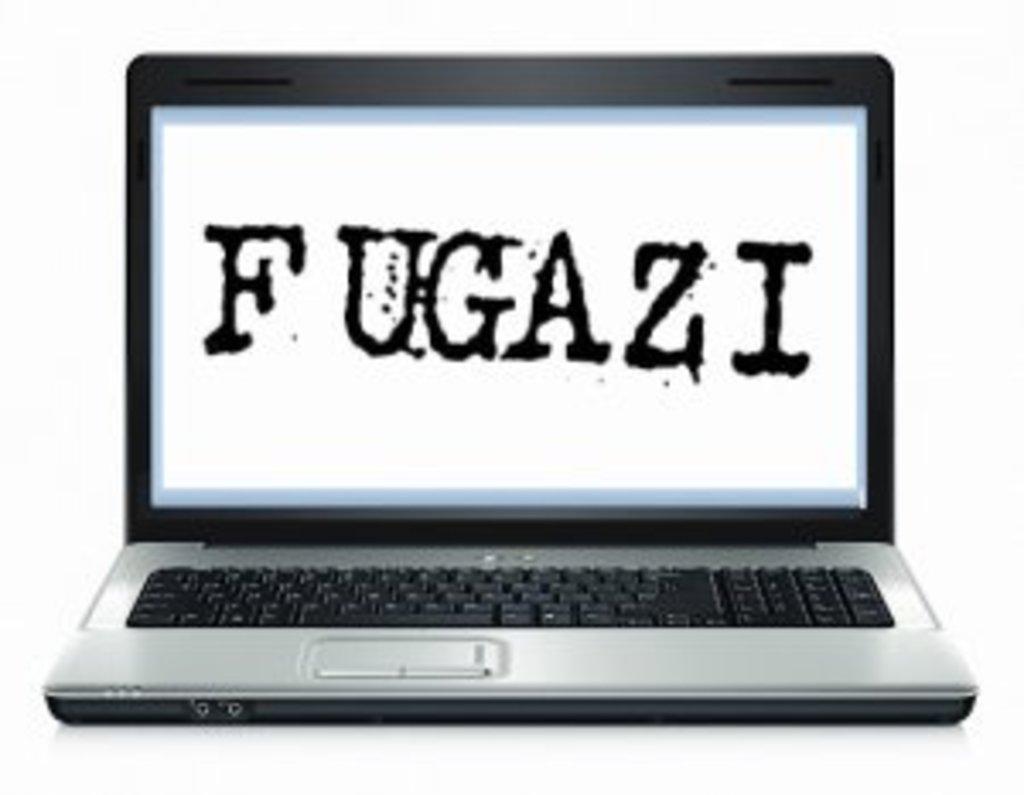What is the word on that computer?
Keep it short and to the point. Fugazi. 